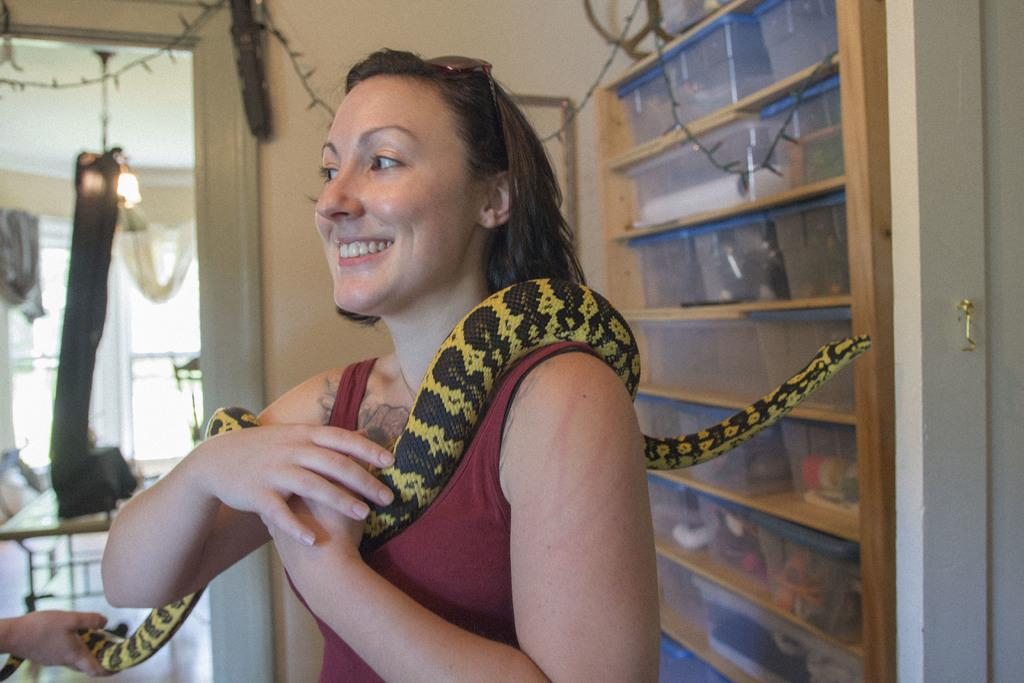Who is present in the image? There is a woman in the picture. What is the woman doing in the image? The woman is smiling. What is unusual about the woman's appearance in the image? There is a snake across the woman's body. What can be seen in the background of the picture? There is a wall and a cupboard in the background of the picture. What type of flag is visible in the image? There is no flag present in the image. Is the woman in the image a fireman? There is no indication in the image that the woman is a fireman. 